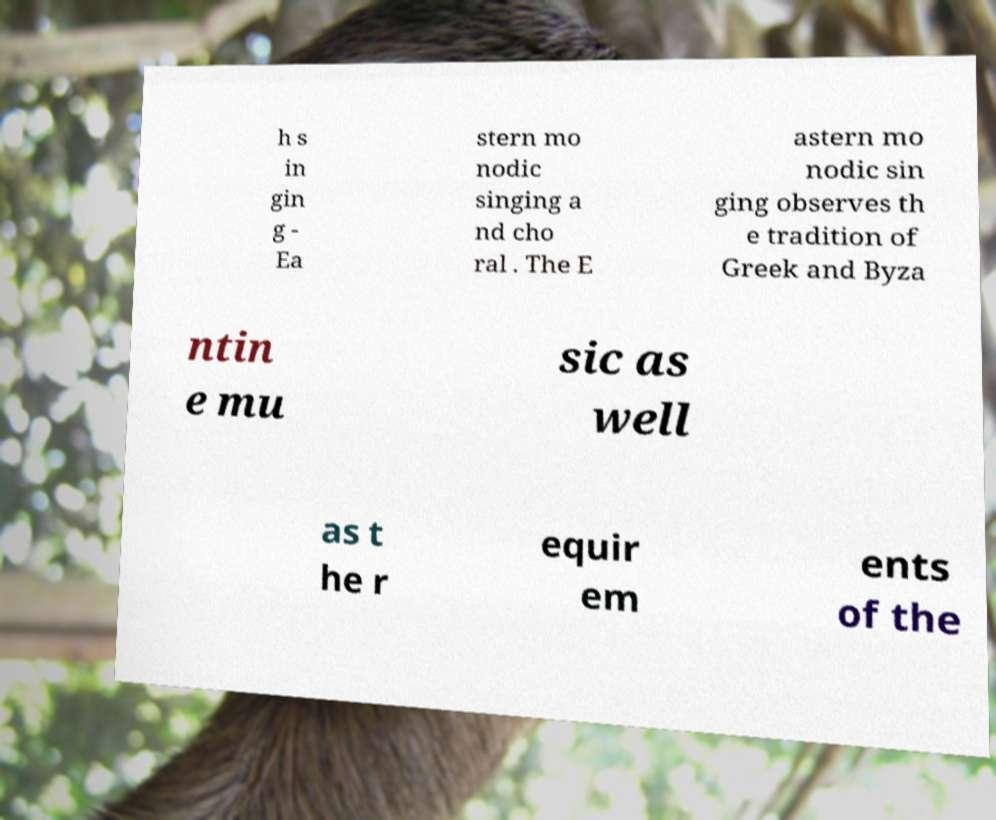What messages or text are displayed in this image? I need them in a readable, typed format. h s in gin g - Ea stern mo nodic singing a nd cho ral . The E astern mo nodic sin ging observes th e tradition of Greek and Byza ntin e mu sic as well as t he r equir em ents of the 